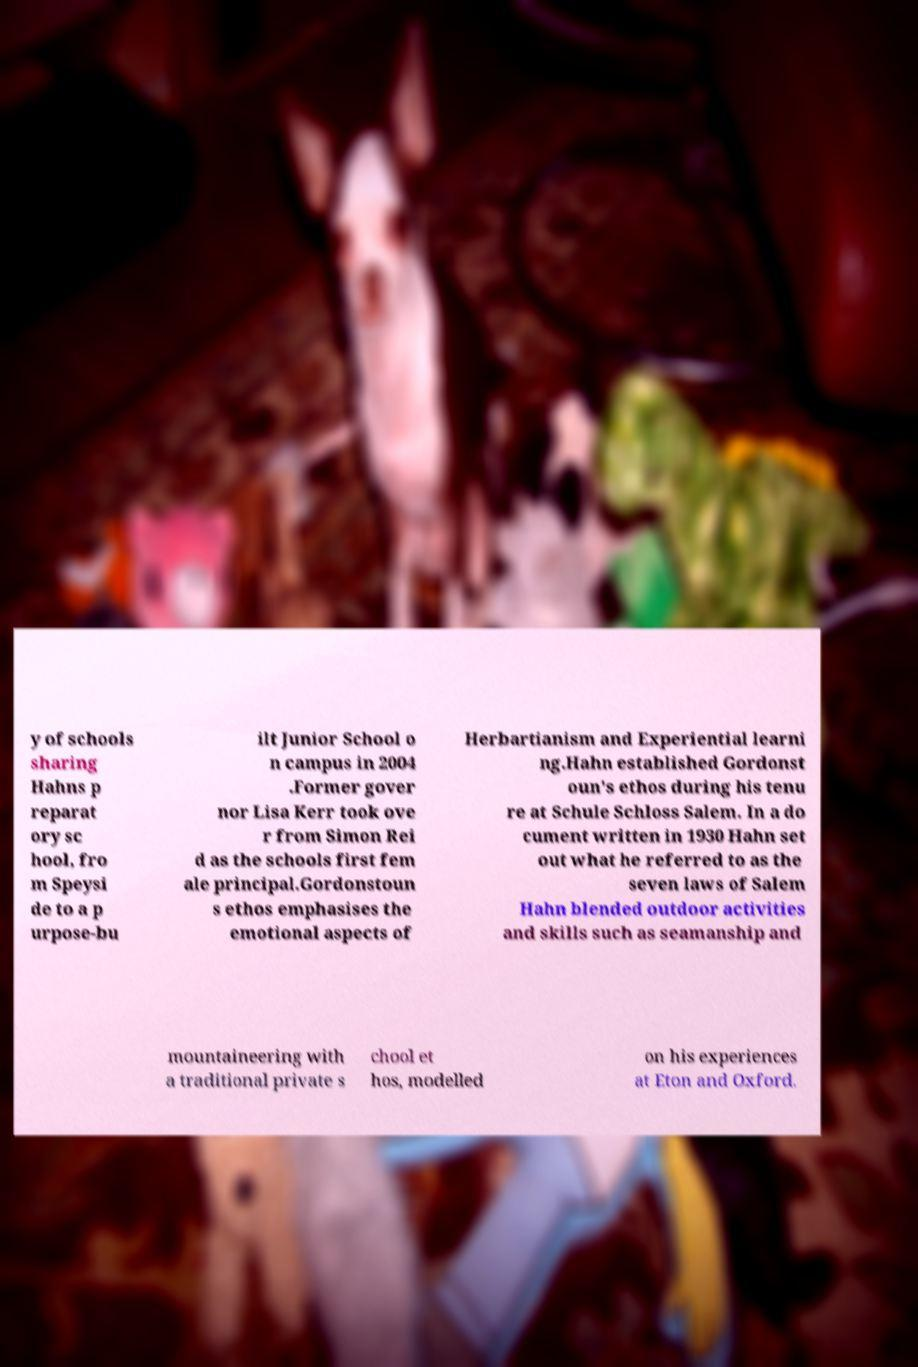Please identify and transcribe the text found in this image. y of schools sharing Hahns p reparat ory sc hool, fro m Speysi de to a p urpose-bu ilt Junior School o n campus in 2004 .Former gover nor Lisa Kerr took ove r from Simon Rei d as the schools first fem ale principal.Gordonstoun s ethos emphasises the emotional aspects of Herbartianism and Experiential learni ng.Hahn established Gordonst oun's ethos during his tenu re at Schule Schloss Salem. In a do cument written in 1930 Hahn set out what he referred to as the seven laws of Salem Hahn blended outdoor activities and skills such as seamanship and mountaineering with a traditional private s chool et hos, modelled on his experiences at Eton and Oxford. 